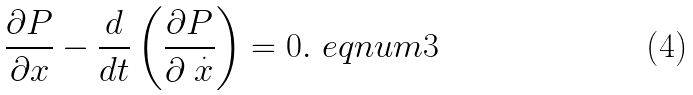Convert formula to latex. <formula><loc_0><loc_0><loc_500><loc_500>\frac { \partial P } { \partial x } - \frac { d } { d t } \left ( \frac { \partial P } { \partial \stackrel { . } { x } } \right ) = 0 . \ e q n u m { 3 }</formula> 